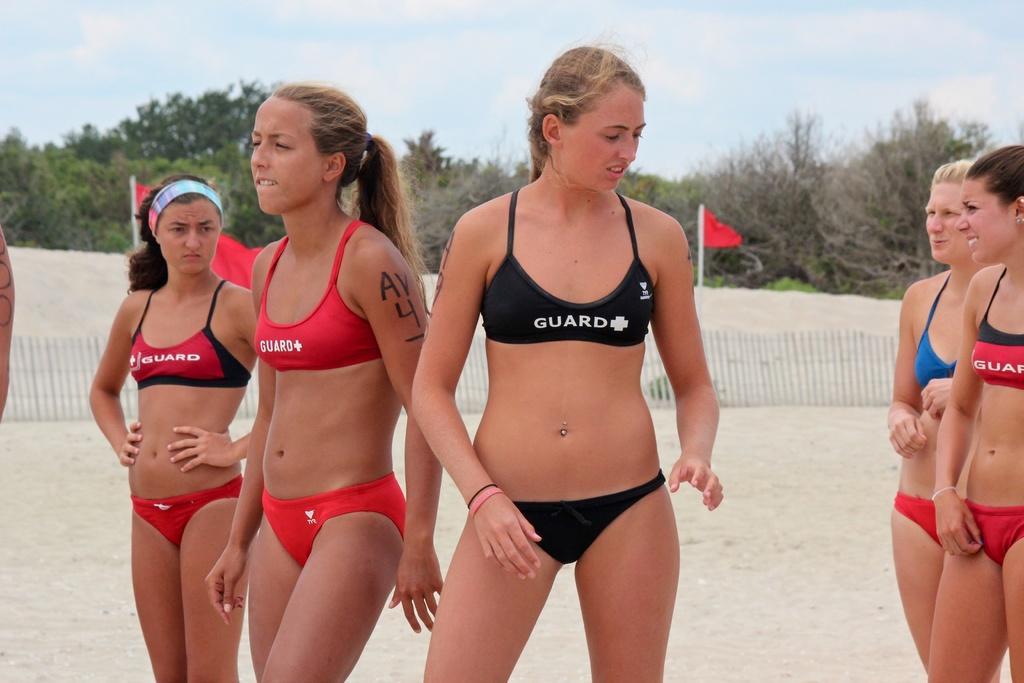How would you summarize this image in a sentence or two? In the foreground of the picture we can see group of women. The picture might be taken in the beach. In the foreground of the picture there is sand. In the middle of the picture there are flags and railing. In the background there are trees and sky. 